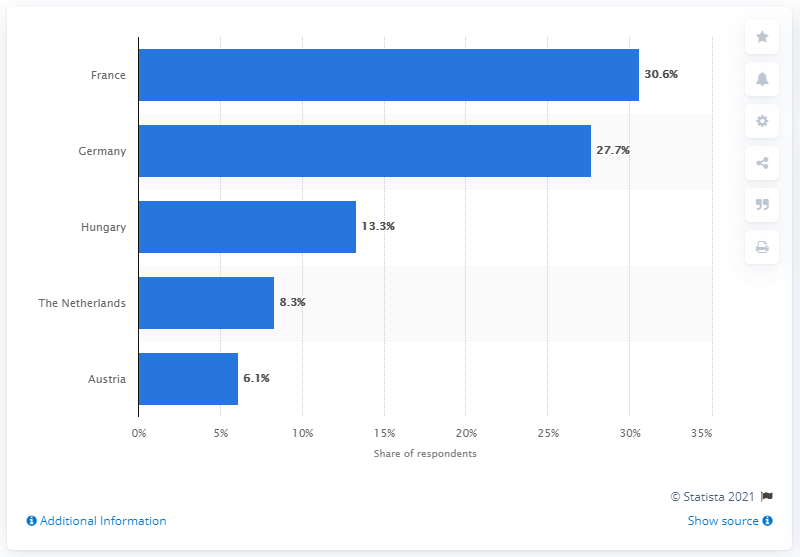Identify some key points in this picture. Germany was the most preferred European river cruise destination for American travelers in 2019. 